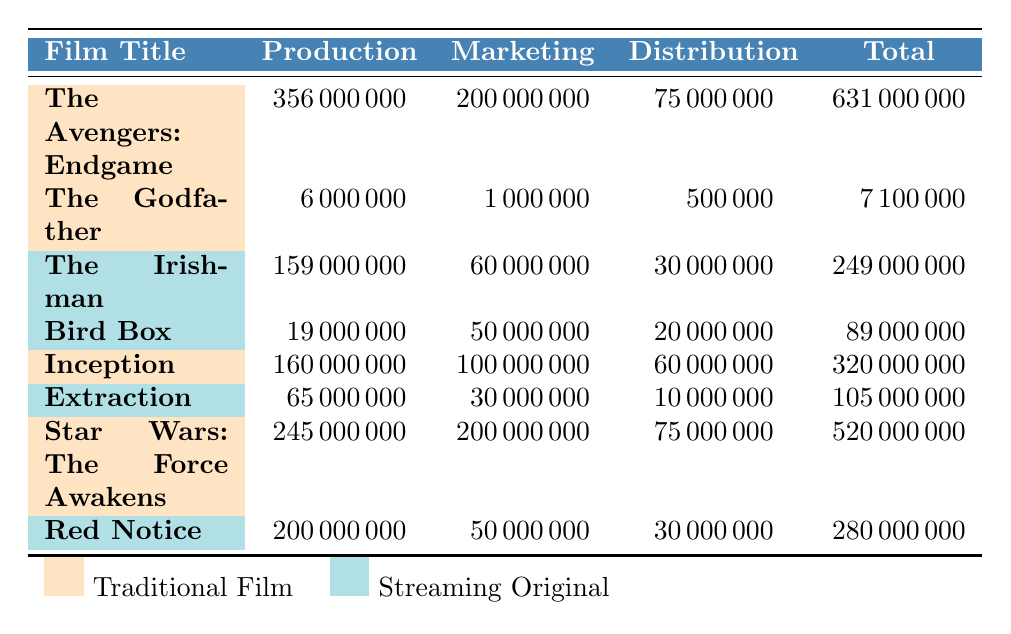What is the production budget for "The Avengers: Endgame"? The table lists "The Avengers: Endgame" under the Traditional Film category, with a production budget of 356,000,000.
Answer: 356000000 Which film has the lowest total budget? Upon reviewing the total budgets listed, "The Godfather" has the lowest total budget of 7,100,000.
Answer: 7100000 How much was spent on marketing for "The Irishman"? In the table, "The Irishman" shows a marketing budget of 60,000,000.
Answer: 60000000 What is the total budget for all traditional films listed? The total budget for all traditional films is the sum of their total budgets: 631,000,000 + 7,100,000 + 320,000,000 + 520,000,000 = 1,478,100,000.
Answer: 1478100000 Which film type has a higher average production budget? Calculate the average production budget for each type: Traditional Films (356M + 6M + 160M + 245M) / 4 = 191.75M; Streaming Originals (159M + 19M + 65M + 200M) / 4 = 108.5M. Traditional Films have a higher average.
Answer: Traditional Films Is the distribution budget for "Bird Box" greater than that of "Extraction"? "Bird Box" has a distribution budget of 20,000,000, while "Extraction" has 10,000,000. Since 20M > 10M, the statement is true.
Answer: Yes What is the total marketing budget for all streaming originals combined? The total marketing budget is calculated as follows: 60,000,000 (The Irishman) + 50,000,000 (Bird Box) + 30,000,000 (Extraction) + 50,000,000 (Red Notice) = 190,000,000.
Answer: 190000000 How much higher is the production budget of "Star Wars: The Force Awakens" compared to "The Irishman"? The production budget for "Star Wars: The Force Awakens" is 245,000,000 and for "The Irishman" it is 159,000,000. The difference is 245,000,000 - 159,000,000 = 86,000,000.
Answer: 86000000 Which film has a total budget that exceeds 200 million? The films with total budgets over 200 million include "The Avengers: Endgame" (631,000,000) and "Star Wars: The Force Awakens" (520,000,000).
Answer: The Avengers: Endgame, Star Wars: The Force Awakens What percentage of the total budget for "Inception" is allocated to marketing? The marketing budget for "Inception" is 100,000,000 and the total budget is 320,000,000. Therefore, the percentage is (100,000,000 / 320,000,000) * 100 = 31.25%.
Answer: 31.25% Which film has the highest distribution budget, and what is the amount? Reviewing the table, "The Avengers: Endgame" has the highest distribution budget of 75,000,000.
Answer: 75000000 